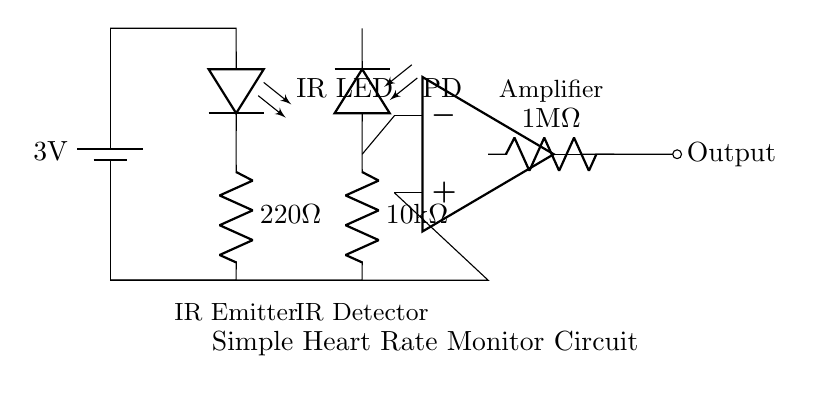What is the voltage of the power supply? The voltage of the power supply is labeled as three volts in the circuit diagram. It is the source of electrical energy for the circuit components.
Answer: 3 volts What type of LED is used in this circuit? The circuit diagram specifically identifies the LED as an infrared LED, which is important for its function in detecting heart rate by reflecting infrared light off of the blood.
Answer: Infrared LED What is the resistance of the feedback resistor? The feedback resistor is shown in the diagram with a resistance value of one megaohm, which indicates its role in controlling the gain of the amplifier stage.
Answer: One megaohm What component detects the infrared light emitted by the IR LED? The photodiode is the component responsible for detecting the infrared light in this circuit, converting the light signals into electrical signals that represent the heart rate.
Answer: Photodiode What is the purpose of the amplifier in the circuit? The amplifier's purpose is to boost the electrical signal received from the photodiode, making it stronger and more suitable for output measurement of the heart rate.
Answer: To boost the signal How is the output of the circuit labeled? The output of the circuit is labeled as “Output” in the diagram, showing where the amplified signal can be measured or connected to further processing units.
Answer: Output 